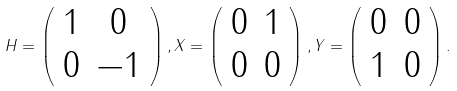<formula> <loc_0><loc_0><loc_500><loc_500>H = \left ( \begin{array} { c c } 1 & 0 \\ 0 & - 1 \end{array} \right ) , X = \left ( \begin{array} { c c } 0 & 1 \\ 0 & 0 \end{array} \right ) , Y = \left ( \begin{array} { c c } 0 & 0 \\ 1 & 0 \end{array} \right ) .</formula> 